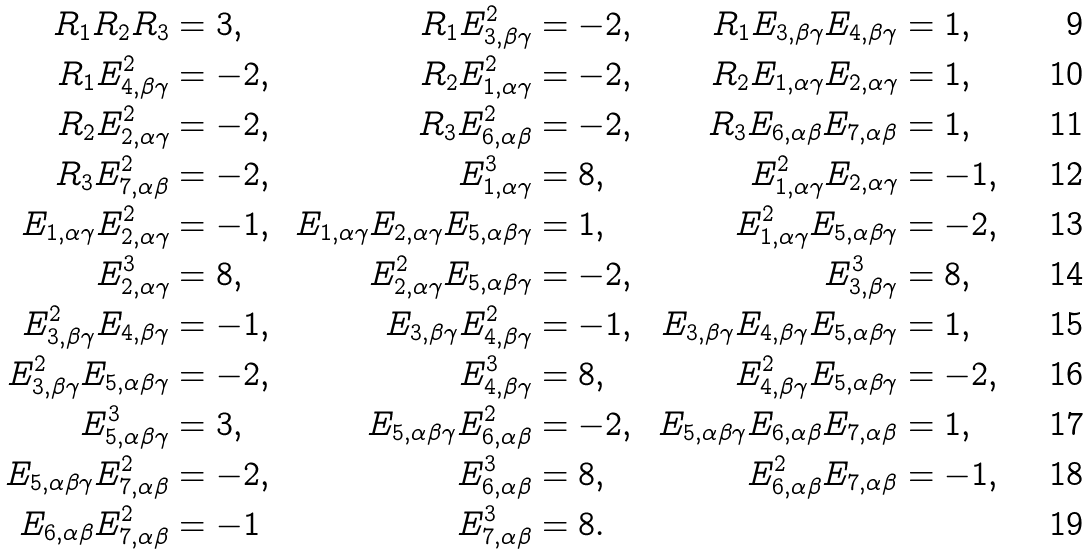Convert formula to latex. <formula><loc_0><loc_0><loc_500><loc_500>R _ { 1 } R _ { 2 } R _ { 3 } & = 3 , & R _ { 1 } E _ { 3 , \beta \gamma } ^ { 2 } & = - 2 , & R _ { 1 } E _ { 3 , \beta \gamma } E _ { 4 , \beta \gamma } & = 1 , \\ R _ { 1 } E _ { 4 , \beta \gamma } ^ { 2 } & = - 2 , & R _ { 2 } E _ { 1 , \alpha \gamma } ^ { 2 } & = - 2 , & R _ { 2 } E _ { 1 , \alpha \gamma } E _ { 2 , \alpha \gamma } & = 1 , \\ R _ { 2 } E _ { 2 , \alpha \gamma } ^ { 2 } & = - 2 , & R _ { 3 } E _ { 6 , \alpha \beta } ^ { 2 } & = - 2 , & R _ { 3 } E _ { 6 , \alpha \beta } E _ { 7 , \alpha \beta } & = 1 , & \\ R _ { 3 } E _ { 7 , \alpha \beta } ^ { 2 } & = - 2 , & E _ { 1 , \alpha \gamma } ^ { 3 } & = 8 , & E _ { 1 , \alpha \gamma } ^ { 2 } E _ { 2 , \alpha \gamma } & = - 1 , \\ E _ { 1 , \alpha \gamma } E _ { 2 , \alpha \gamma } ^ { 2 } & = - 1 , & E _ { 1 , \alpha \gamma } E _ { 2 , \alpha \gamma } E _ { 5 , \alpha \beta \gamma } & = 1 , & E _ { 1 , \alpha \gamma } ^ { 2 } E _ { 5 , \alpha \beta \gamma } & = - 2 , & \\ E _ { 2 , \alpha \gamma } ^ { 3 } & = 8 , & E _ { 2 , \alpha \gamma } ^ { 2 } E _ { 5 , \alpha \beta \gamma } & = - 2 , & E _ { 3 , \beta \gamma } ^ { 3 } & = 8 , \\ E _ { 3 , \beta \gamma } ^ { 2 } E _ { 4 , \beta \gamma } & = - 1 , & E _ { 3 , \beta \gamma } E _ { 4 , \beta \gamma } ^ { 2 } & = - 1 , & E _ { 3 , \beta \gamma } E _ { 4 , \beta \gamma } E _ { 5 , \alpha \beta \gamma } & = 1 , & \\ E _ { 3 , \beta \gamma } ^ { 2 } E _ { 5 , \alpha \beta \gamma } & = - 2 , & E _ { 4 , \beta \gamma } ^ { 3 } & = 8 , & E _ { 4 , \beta \gamma } ^ { 2 } E _ { 5 , \alpha \beta \gamma } & = - 2 , \\ E _ { 5 , \alpha \beta \gamma } ^ { 3 } & = 3 , & E _ { 5 , \alpha \beta \gamma } E _ { 6 , \alpha \beta } ^ { 2 } & = - 2 , & E _ { 5 , \alpha \beta \gamma } E _ { 6 , \alpha \beta } E _ { 7 , \alpha \beta } & = 1 , \\ E _ { 5 , \alpha \beta \gamma } E _ { 7 , \alpha \beta } ^ { 2 } & = - 2 , & E _ { 6 , \alpha \beta } ^ { 3 } & = 8 , & E _ { 6 , \alpha \beta } ^ { 2 } E _ { 7 , \alpha \beta } & = - 1 , \\ E _ { 6 , \alpha \beta } E _ { 7 , \alpha \beta } ^ { 2 } & = - 1 & E _ { 7 , \alpha \beta } ^ { 3 } & = 8 .</formula> 